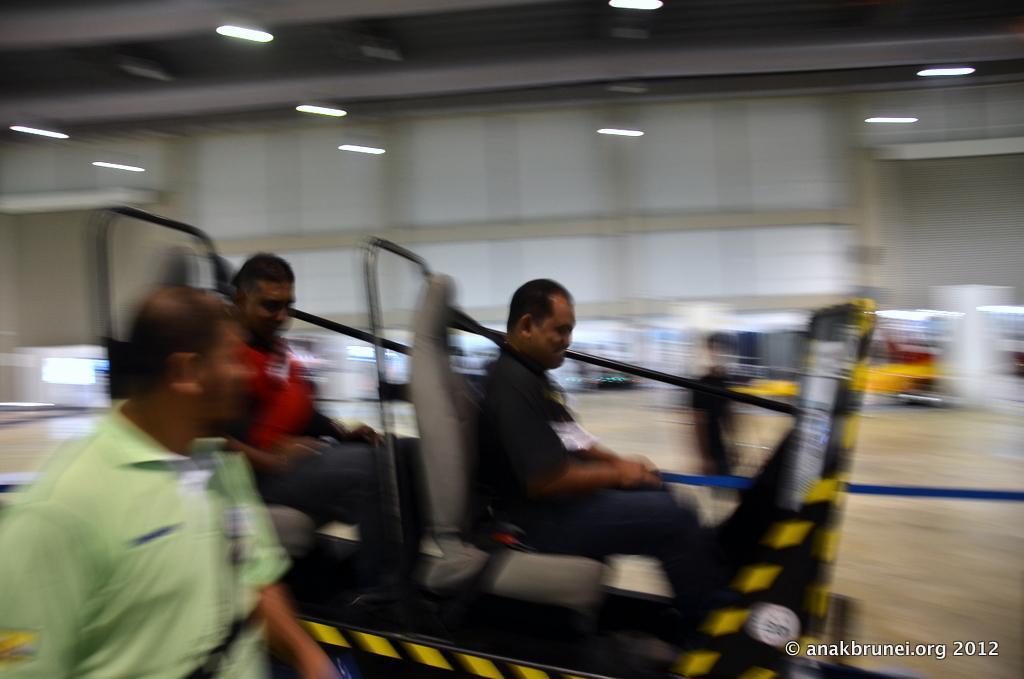Please provide a concise description of this image. This is a blur image. In this image, in the middle and on the left side, we can see three men are sitting and a riding on the vehicle. In the background, we can see a person. At the top, we can see a roof with few lights. 